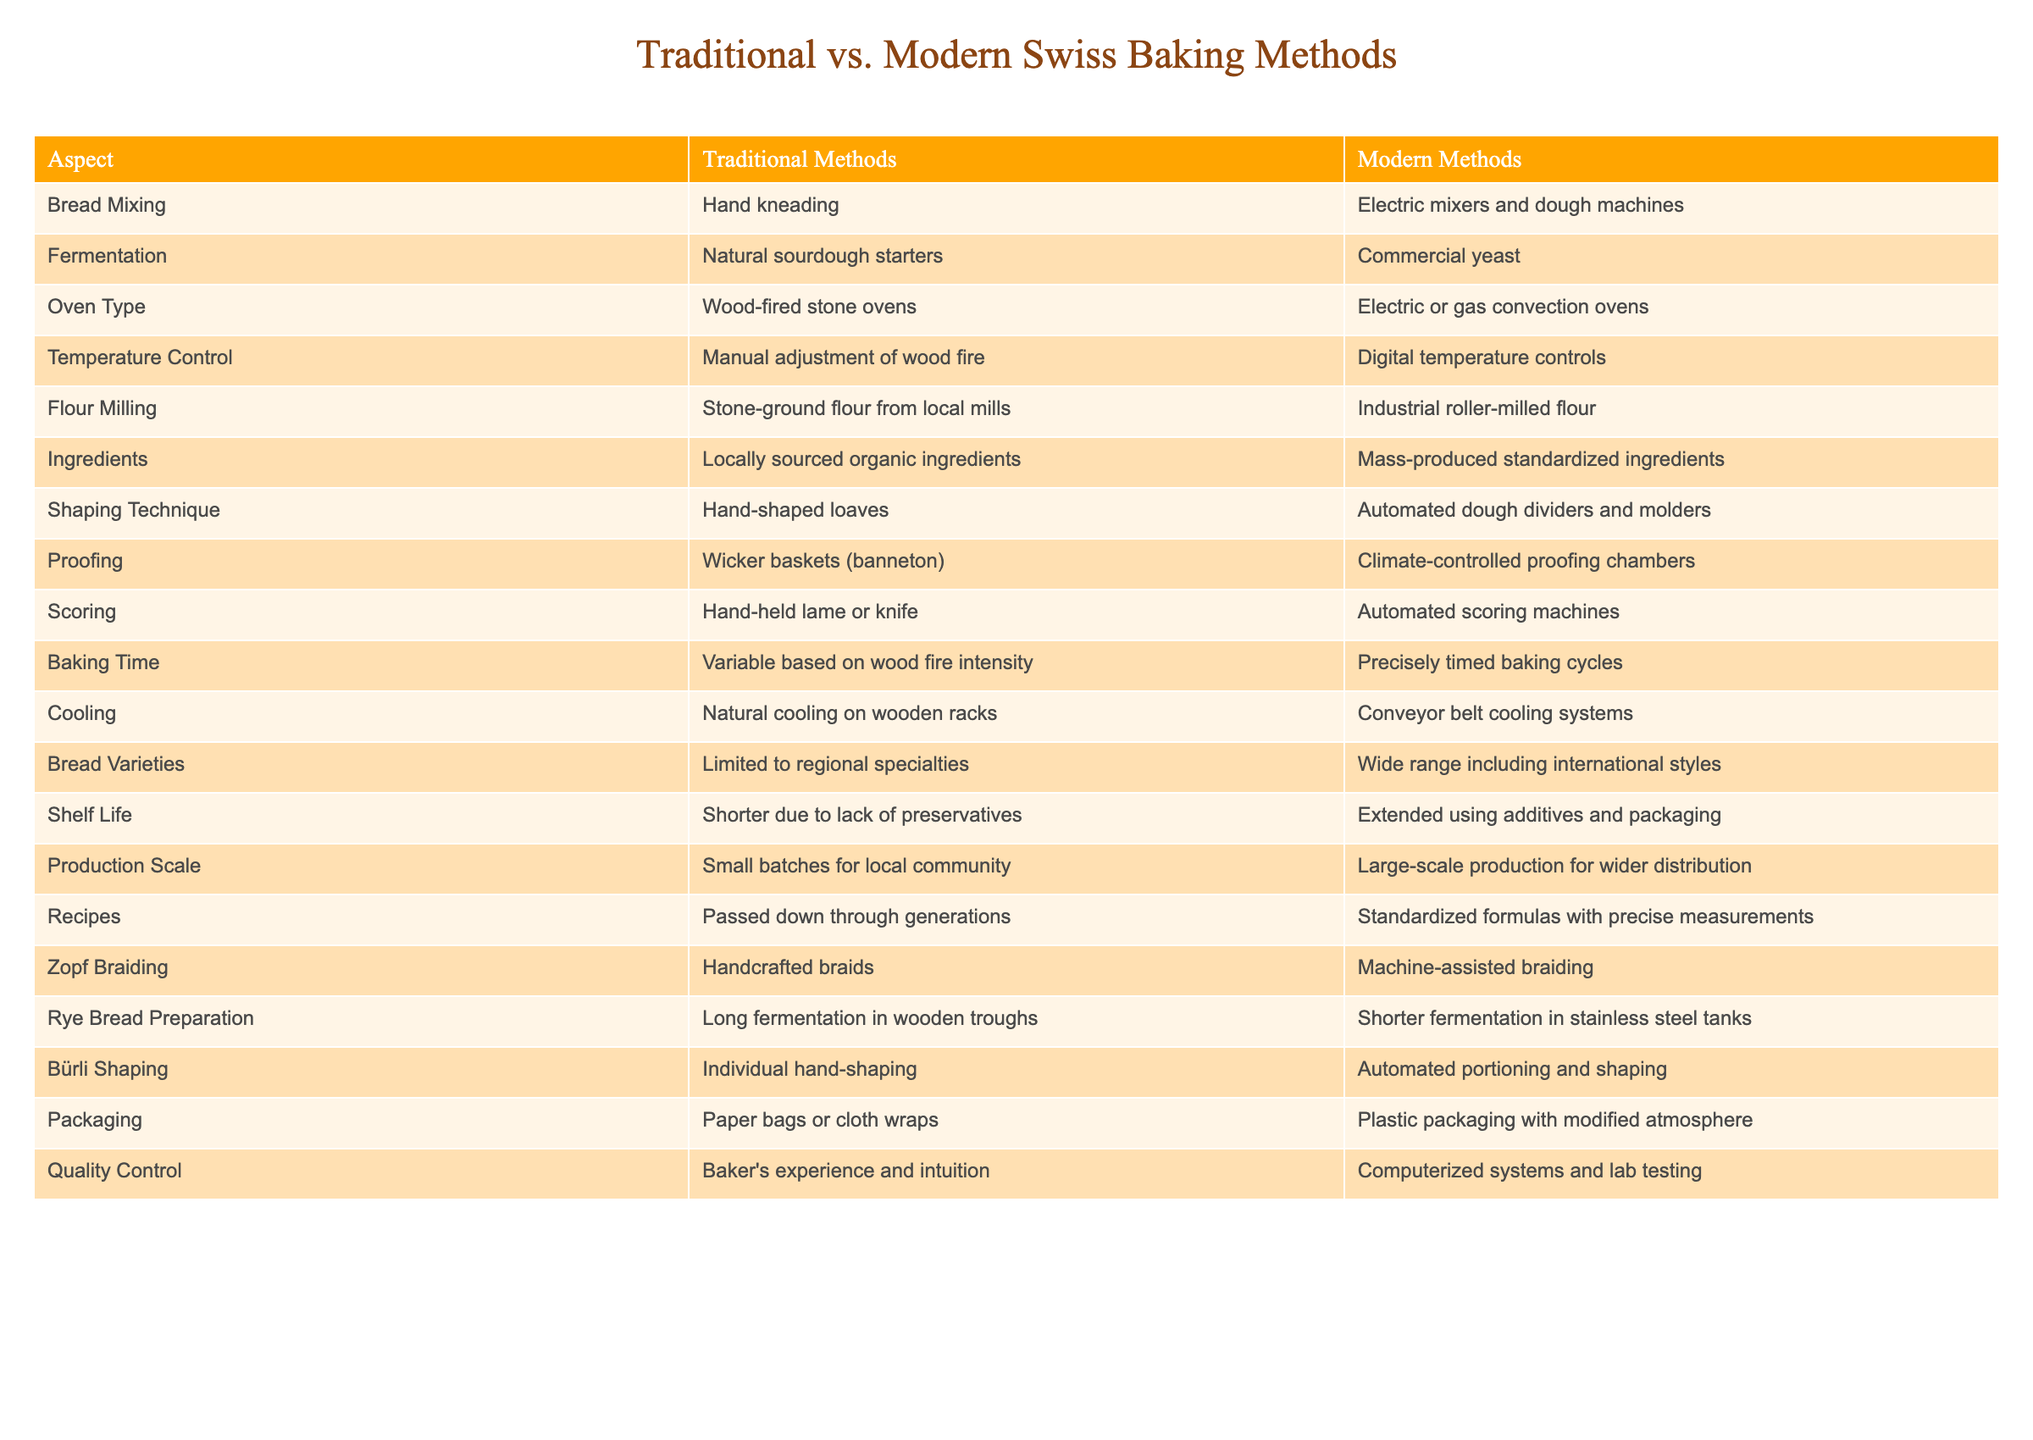What is the primary method for mixing bread in traditional Swiss baking? According to the table, the primary method for mixing bread in traditional Swiss baking is hand kneading. This is clearly stated in the "Bread Mixing" row under the "Traditional Methods" column.
Answer: Hand kneading Is commercial yeast used in modern baking? Yes, the table specifies that commercial yeast is used for fermentation in modern methods. It is listed directly under the "Fermentation" aspect in the "Modern Methods" column.
Answer: Yes How do the baking times compare between traditional and modern methods? Traditional baking times vary based on wood fire intensity, while modern baking methods involve precisely timed baking cycles. This comparison can be found in the "Baking Time" row of the table.
Answer: Traditional: Variable, Modern: Precisely timed What is the difference in shelf life between traditional and modern bread? The table indicates that traditional bread has a shorter shelf life due to the lack of preservatives, while modern bread has an extended shelf life thanks to additives and packaging. This is explained in the "Shelf Life" row.
Answer: Traditional: Shorter, Modern: Extended Which shaping technique involves hand work? The shaping technique involving hand work is hand-shaped loaves, as indicated in the "Shaping Technique" row under traditional methods. This row distinctly mentions hand shaping for traditional approaches.
Answer: Hand-shaped loaves How do quality control methods differ between traditional and modern baking? Traditional quality control relies on the baker's experience and intuition, while modern techniques use computerized systems and lab testing. The table explicitly describes this in the "Quality Control" row.
Answer: Traditional: Experience, Modern: Computerized systems Are all ingredients locally sourced in modern baking? No, the table reveals that modern methods use mass-produced standardized ingredients rather than locally sourced ones, contrasting it with traditional methods that emphasize local sourcing.
Answer: No What is the primary difference in the fermentation process between the two methods? The primary difference is that traditional methods use natural sourdough starters, while modern methods rely on commercial yeast. This is detailed in the "Fermentation" row across both methods in the table.
Answer: Natural starters vs. commercial yeast How might the choice of flour affect the bread varieties produced? The table shows that traditional methods use stone-ground flour from local mills, which typically contributes to regional flavors and specialties. In contrast, modern methods use industrial roller-milled flour, which can affect the range of bread varieties, allowing for a wider range of international styles. This relationship is implied through the "Flour Milling" and "Bread Varieties" aspects.
Answer: Traditional: Regional specialties, Modern: Wide range 